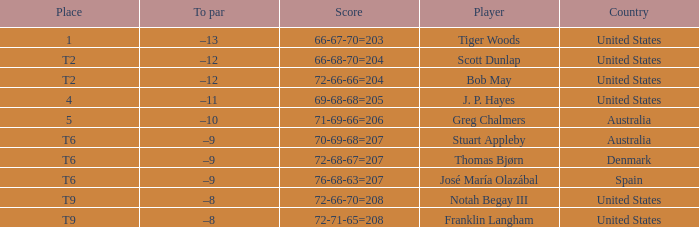What is the place of the player with a 66-68-70=204 score? T2. 